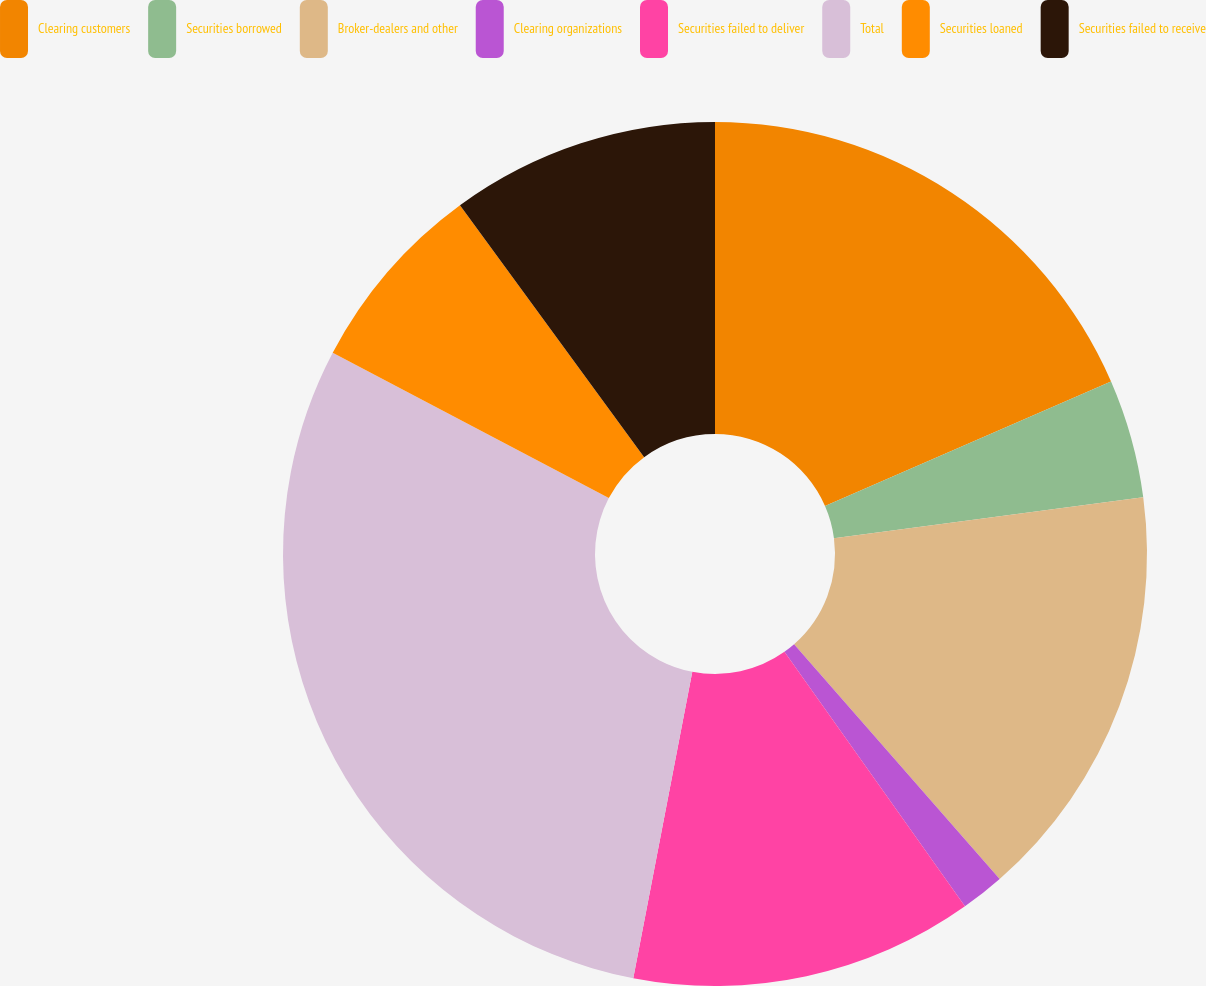Convert chart to OTSL. <chart><loc_0><loc_0><loc_500><loc_500><pie_chart><fcel>Clearing customers<fcel>Securities borrowed<fcel>Broker-dealers and other<fcel>Clearing organizations<fcel>Securities failed to deliver<fcel>Total<fcel>Securities loaned<fcel>Securities failed to receive<nl><fcel>18.46%<fcel>4.44%<fcel>15.65%<fcel>1.63%<fcel>12.85%<fcel>29.68%<fcel>7.24%<fcel>10.05%<nl></chart> 